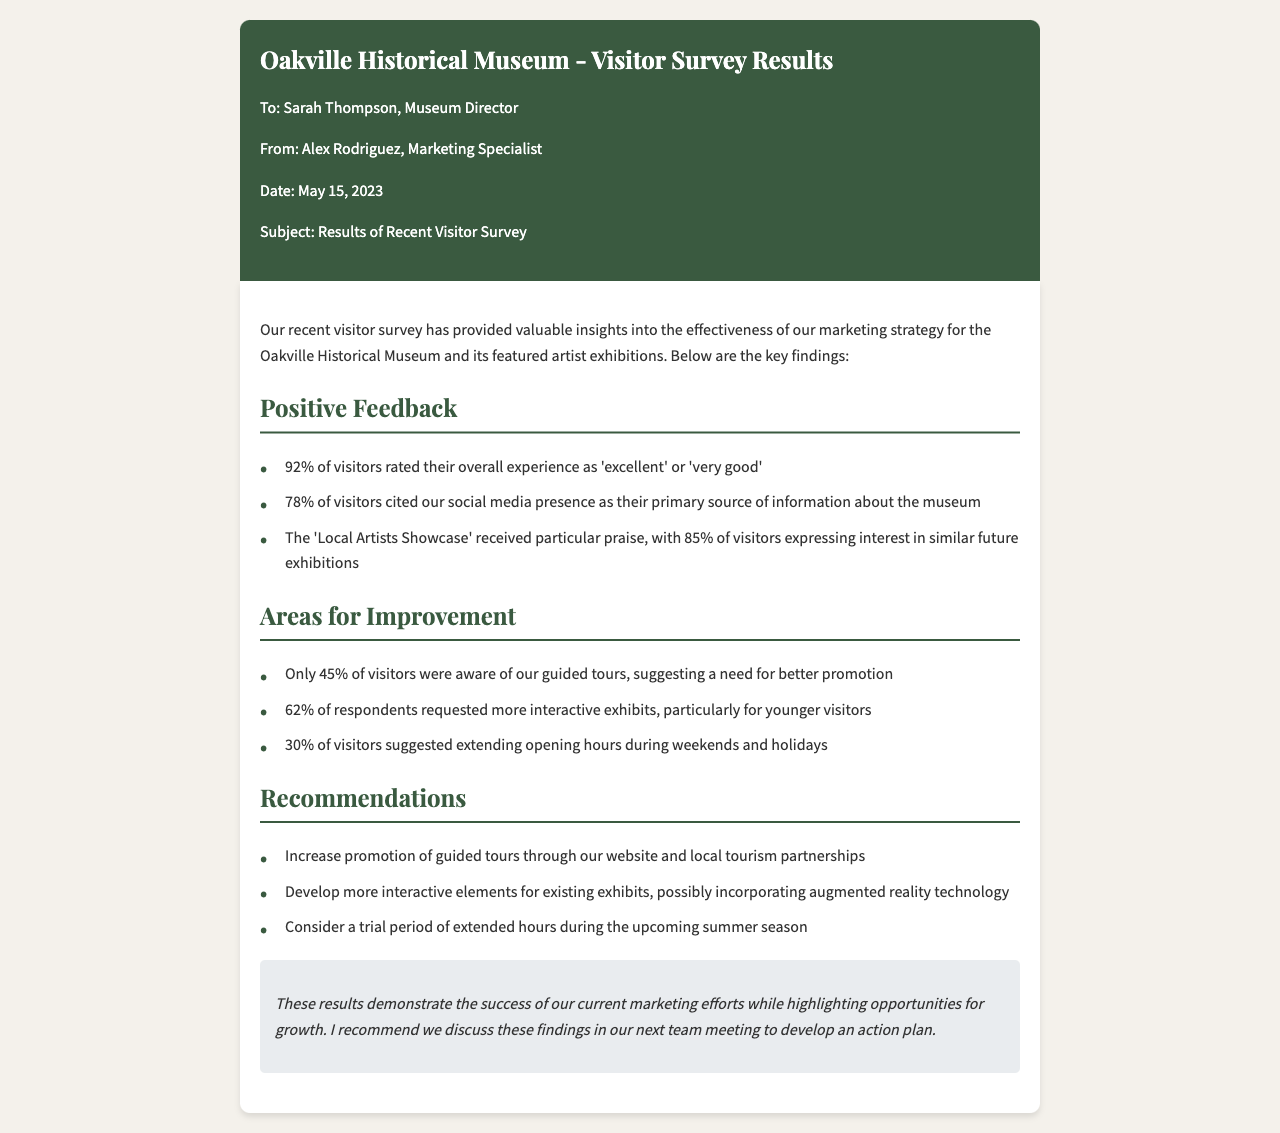what percentage of visitors rated their experience as 'excellent' or 'very good'? The document states that 92% of visitors rated their overall experience positively.
Answer: 92% what was the primary source of information for 78% of visitors? The document mentions that 78% cited social media presence as their main source.
Answer: social media presence what percentage of visitors expressed interest in similar future exhibitions to the 'Local Artists Showcase'? 85% of visitors showed interest in future exhibitions similar to the 'Local Artists Showcase'.
Answer: 85% how many visitors were aware of the guided tours? The survey indicates that only 45% of visitors were aware of the guided tours.
Answer: 45% what is one suggestion for improving visitor engagement with the exhibits? The document states that 62% requested more interactive exhibits for younger visitors.
Answer: more interactive exhibits what is the recommended action regarding guided tours? The recommendation includes increasing promotion of guided tours.
Answer: increase promotion what percentage of visitors suggested extending opening hours? 30% of visitors suggested extending opening hours during weekends and holidays.
Answer: 30% who is the sender of the fax? The sender of the fax is Alex Rodriguez, the Marketing Specialist.
Answer: Alex Rodriguez what is the date of the fax? The date of the fax is mentioned as May 15, 2023.
Answer: May 15, 2023 